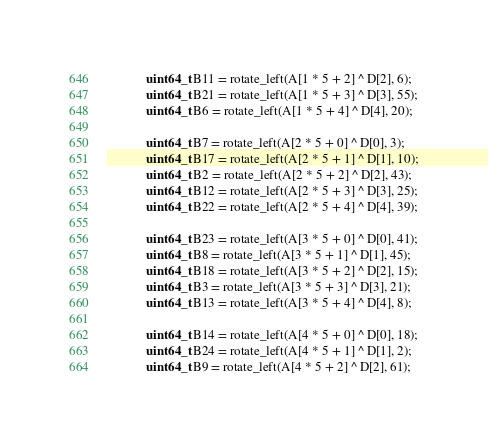Convert code to text. <code><loc_0><loc_0><loc_500><loc_500><_C++_>			uint64_t B11 = rotate_left(A[1 * 5 + 2] ^ D[2], 6);
			uint64_t B21 = rotate_left(A[1 * 5 + 3] ^ D[3], 55);
			uint64_t B6 = rotate_left(A[1 * 5 + 4] ^ D[4], 20);

			uint64_t B7 = rotate_left(A[2 * 5 + 0] ^ D[0], 3);
			uint64_t B17 = rotate_left(A[2 * 5 + 1] ^ D[1], 10);
			uint64_t B2 = rotate_left(A[2 * 5 + 2] ^ D[2], 43);
			uint64_t B12 = rotate_left(A[2 * 5 + 3] ^ D[3], 25);
			uint64_t B22 = rotate_left(A[2 * 5 + 4] ^ D[4], 39);

			uint64_t B23 = rotate_left(A[3 * 5 + 0] ^ D[0], 41);
			uint64_t B8 = rotate_left(A[3 * 5 + 1] ^ D[1], 45);
			uint64_t B18 = rotate_left(A[3 * 5 + 2] ^ D[2], 15);
			uint64_t B3 = rotate_left(A[3 * 5 + 3] ^ D[3], 21);
			uint64_t B13 = rotate_left(A[3 * 5 + 4] ^ D[4], 8);

			uint64_t B14 = rotate_left(A[4 * 5 + 0] ^ D[0], 18);
			uint64_t B24 = rotate_left(A[4 * 5 + 1] ^ D[1], 2);
			uint64_t B9 = rotate_left(A[4 * 5 + 2] ^ D[2], 61);</code> 